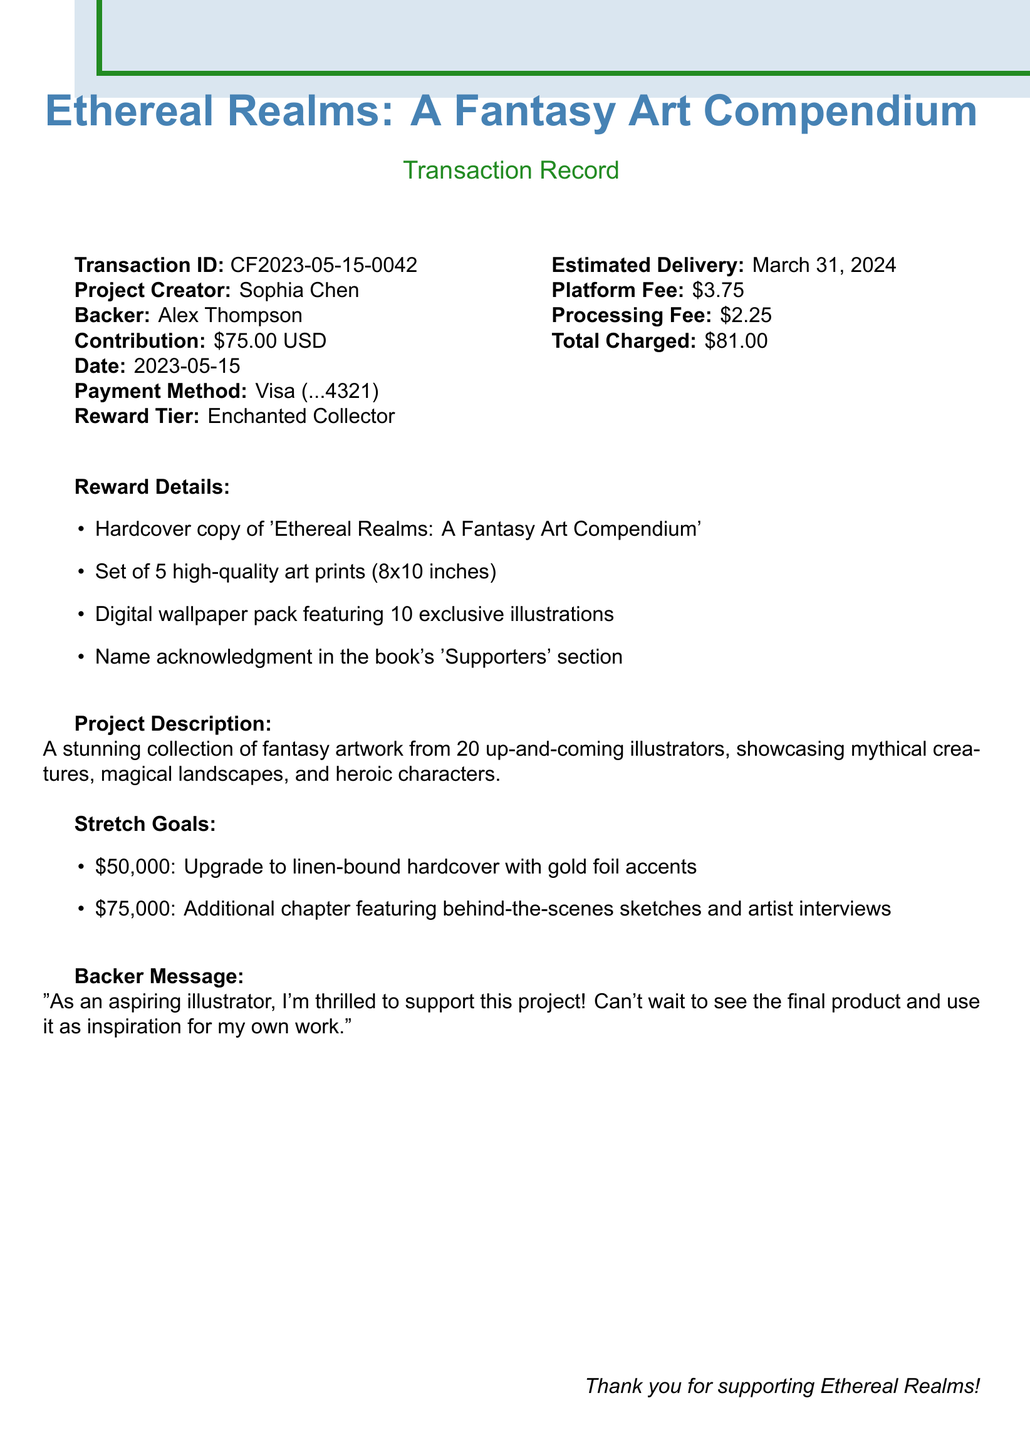What is the transaction ID? The transaction ID is specified as a unique identifier within the document.
Answer: CF2023-05-15-0042 Who is the project creator? The project creator's name is mentioned clearly in the document as the person behind the art compendium.
Answer: Sophia Chen What is the contribution amount? The document lists the specific amount contributed by the backer for the project.
Answer: $75.00 What is the estimated delivery date? The estimated delivery date indicates when backers can expect to receive their rewards.
Answer: March 31, 2024 What is the reward tier? This represents the specific level of contribution and associated benefits in the crowdfunding campaign.
Answer: Enchanted Collector How many high-quality art prints are included in the reward? The number of art prints included in the rewards package is outlined in the reward details.
Answer: 5 What stretch goal is associated with $75,000? This represents the additional content promised if the crowdfunding project reaches a certain financial milestone.
Answer: Additional chapter featuring behind-the-scenes sketches and artist interviews What payment method was used? The document specifies the type of payment method utilized by the backer for their contribution.
Answer: Credit Card (Visa ending in 4321) What is the total charged amount? The document states the total amount charged from the backer, including fees.
Answer: $81.00 